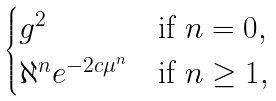Convert formula to latex. <formula><loc_0><loc_0><loc_500><loc_500>\begin{cases} g ^ { 2 } & \text {if $n=0$} , \\ \aleph ^ { n } e ^ { - 2 c \mu ^ { n } } & \text {if $n\geq 1$} , \end{cases}</formula> 